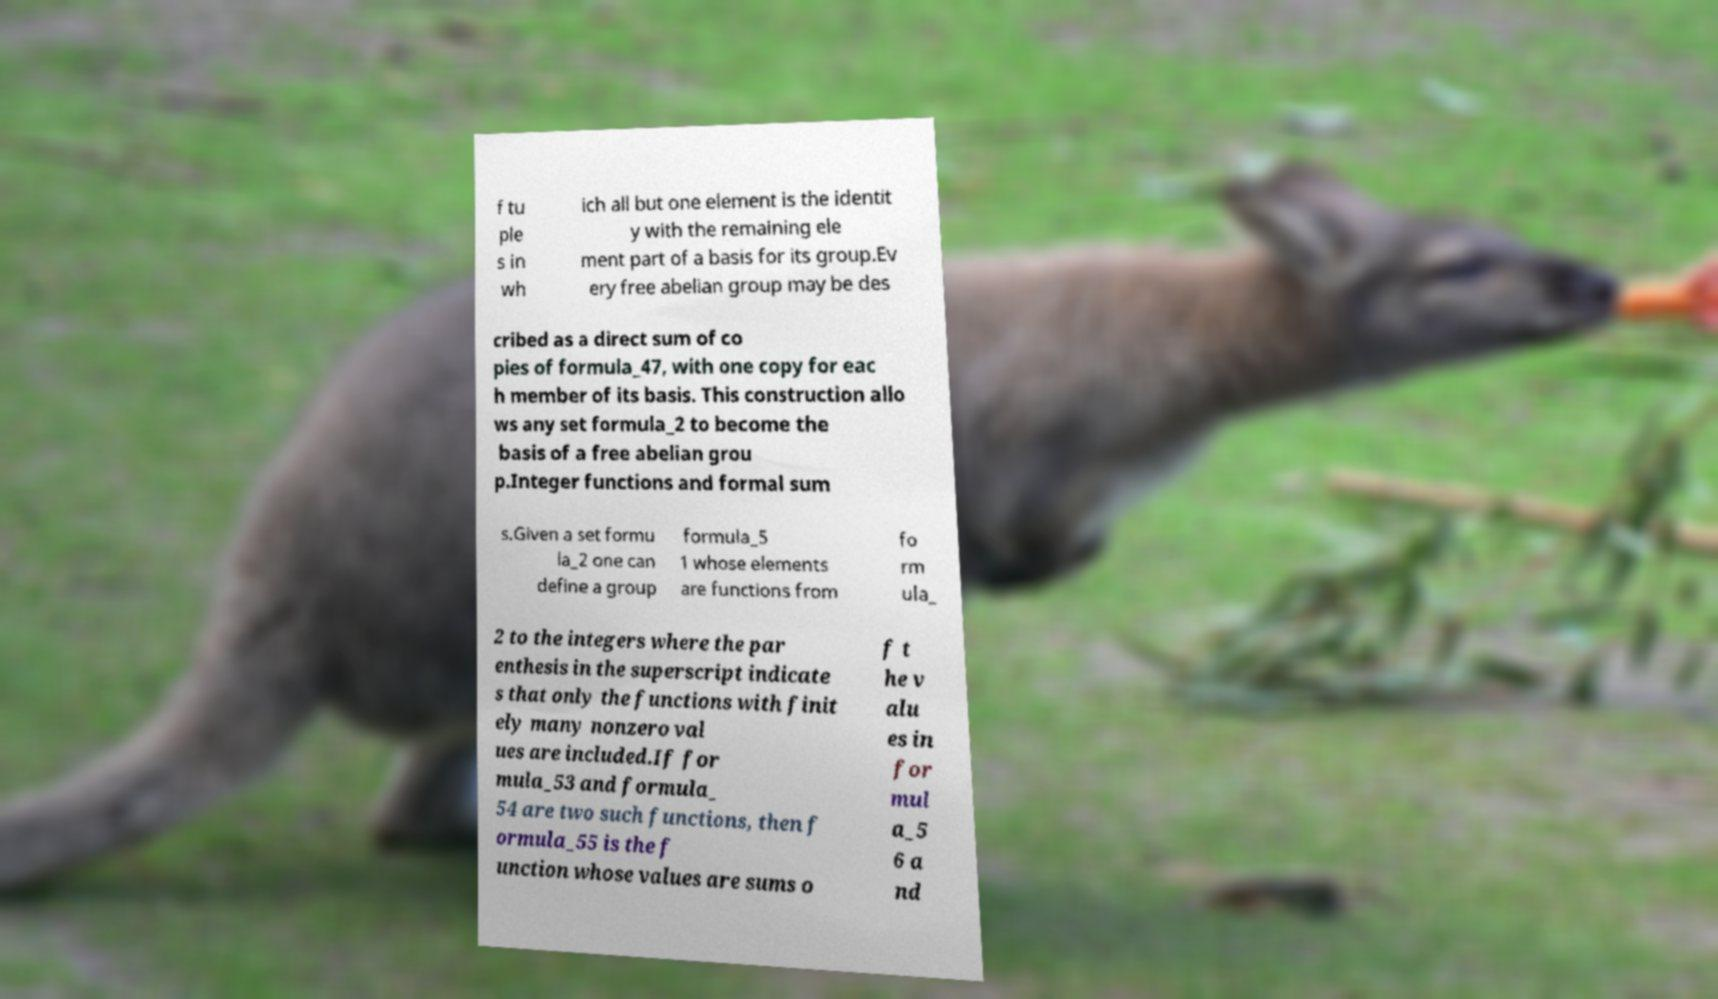There's text embedded in this image that I need extracted. Can you transcribe it verbatim? f tu ple s in wh ich all but one element is the identit y with the remaining ele ment part of a basis for its group.Ev ery free abelian group may be des cribed as a direct sum of co pies of formula_47, with one copy for eac h member of its basis. This construction allo ws any set formula_2 to become the basis of a free abelian grou p.Integer functions and formal sum s.Given a set formu la_2 one can define a group formula_5 1 whose elements are functions from fo rm ula_ 2 to the integers where the par enthesis in the superscript indicate s that only the functions with finit ely many nonzero val ues are included.If for mula_53 and formula_ 54 are two such functions, then f ormula_55 is the f unction whose values are sums o f t he v alu es in for mul a_5 6 a nd 